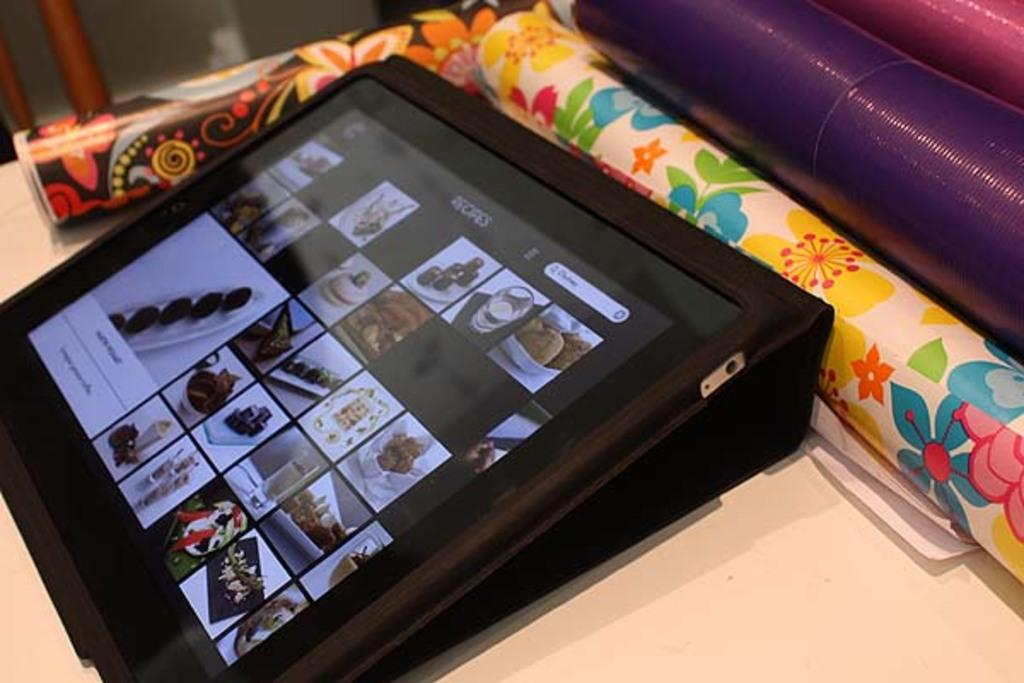What is the main object in the image with a screen? There is a tab with a screen in the image. What is being displayed on the screen? The screen is displaying images. What can be seen on the table in the image? There are rolls arranged on a table in the image. How many geese are flying in the background of the image? There are no geese visible in the image; it only features a tab with a screen and rolls on a table. 